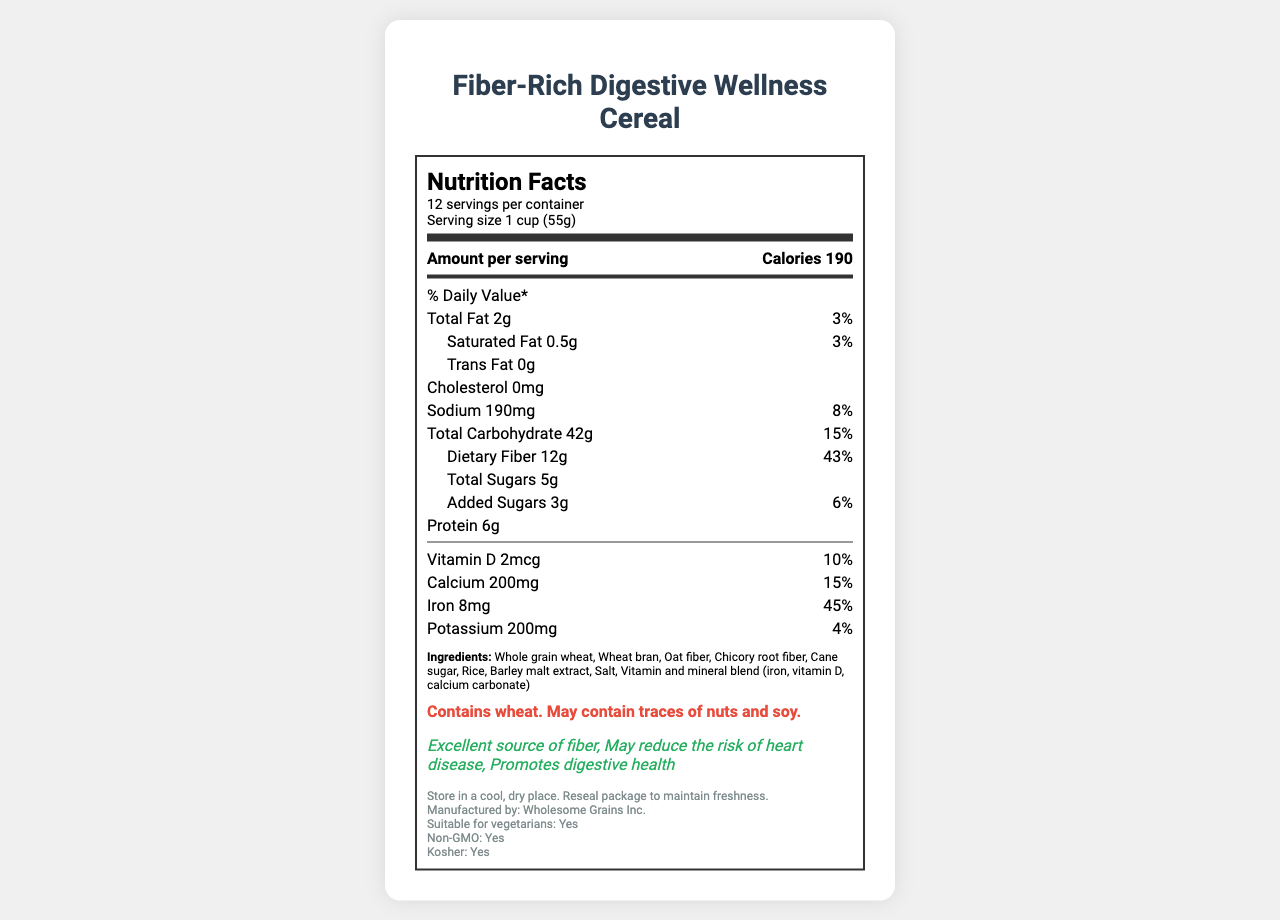what is the serving size? The serving size is listed right after the product name and serving per container, showing "Serving size 1 cup (55g)".
Answer: 1 cup (55g) how many servings are there per container? Under the serving info section, it specifies "12 servings per container".
Answer: 12 how much dietary fiber is in one serving? The dietary fiber content is listed within the nutrition facts under "Dietary Fiber", specifying "12g".
Answer: 12g what percentage of the daily value for iron does one serving provide? The percentage of the daily value for iron is listed in the nutrition facts under "Iron", which is 45%.
Answer: 45% which ingredient is listed first? The ingredients list starts with "Whole grain wheat", indicating it is the primary ingredient.
Answer: Whole grain wheat does this cereal contain any cholesterol? According to the nutrition facts, the cholesterol content is listed as "0mg".
Answer: No how many grams of protein are in one serving? The amount of protein per serving is listed under the nutrition facts, showing "6g".
Answer: 6g what is the total carbohydrate content per serving? A. 30g B. 42g C. 45g D. 50g In the nutrition facts, the total carbohydrate content is listed as "42g".
Answer: B. 42g how many calories are there per serving? A. 150 B. 190 C. 200 D. 210 Another part of the nutrition facts lists "Calories 190" under the amount per serving.
Answer: B. 190 is this cereal suitable for vegetarians? In the additional info section, it indicates "Suitable for vegetarians: Yes".
Answer: Yes describe the main idea of the document. The explanation encapsulates the comprehensive nature of the document, including nutritional values, ingredients, allergen info, health claims, storage instructions, and other beneficial qualities.
Answer: The document is a detailed nutritional breakdown of "Fiber-Rich Digestive Wellness Cereal", highlighting its serving size, calories, and various nutritional contents per serving. It also includes ingredient information, allergen warnings, health claims, storage instructions, and additional benefits such as being non-GMO and kosher. how many grams of saturated fat does one serving contain? The saturated fat content is specified under the nutrition facts, listing "0.5g".
Answer: 0.5g is this cereal kosher? Under the additional info, it confirms "Kosher: Yes".
Answer: Yes is there any information about the sugar content in the cereal? The total sugars and added sugars are listed in the nutrition facts, with amounts "Total Sugars 5g" and "Added Sugars 3g".
Answer: Yes does the document mention manufacturing details? The document specifies "Manufactured by: Wholesome Grains Inc." in the additional info section.
Answer: Yes does this cereal contain soy directly? The allergen info states it "May contain traces of nuts and soy," but does not definitively say it contains soy.
Answer: Cannot be determined 